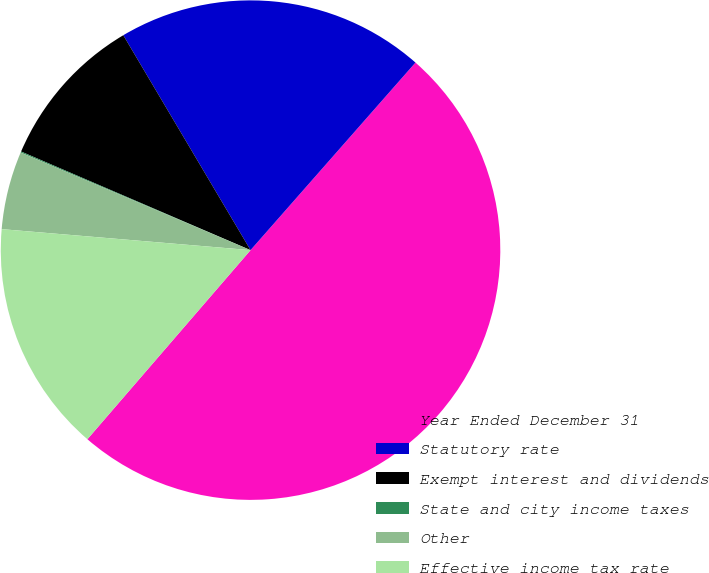Convert chart to OTSL. <chart><loc_0><loc_0><loc_500><loc_500><pie_chart><fcel>Year Ended December 31<fcel>Statutory rate<fcel>Exempt interest and dividends<fcel>State and city income taxes<fcel>Other<fcel>Effective income tax rate<nl><fcel>49.85%<fcel>19.99%<fcel>10.03%<fcel>0.07%<fcel>5.05%<fcel>15.01%<nl></chart> 